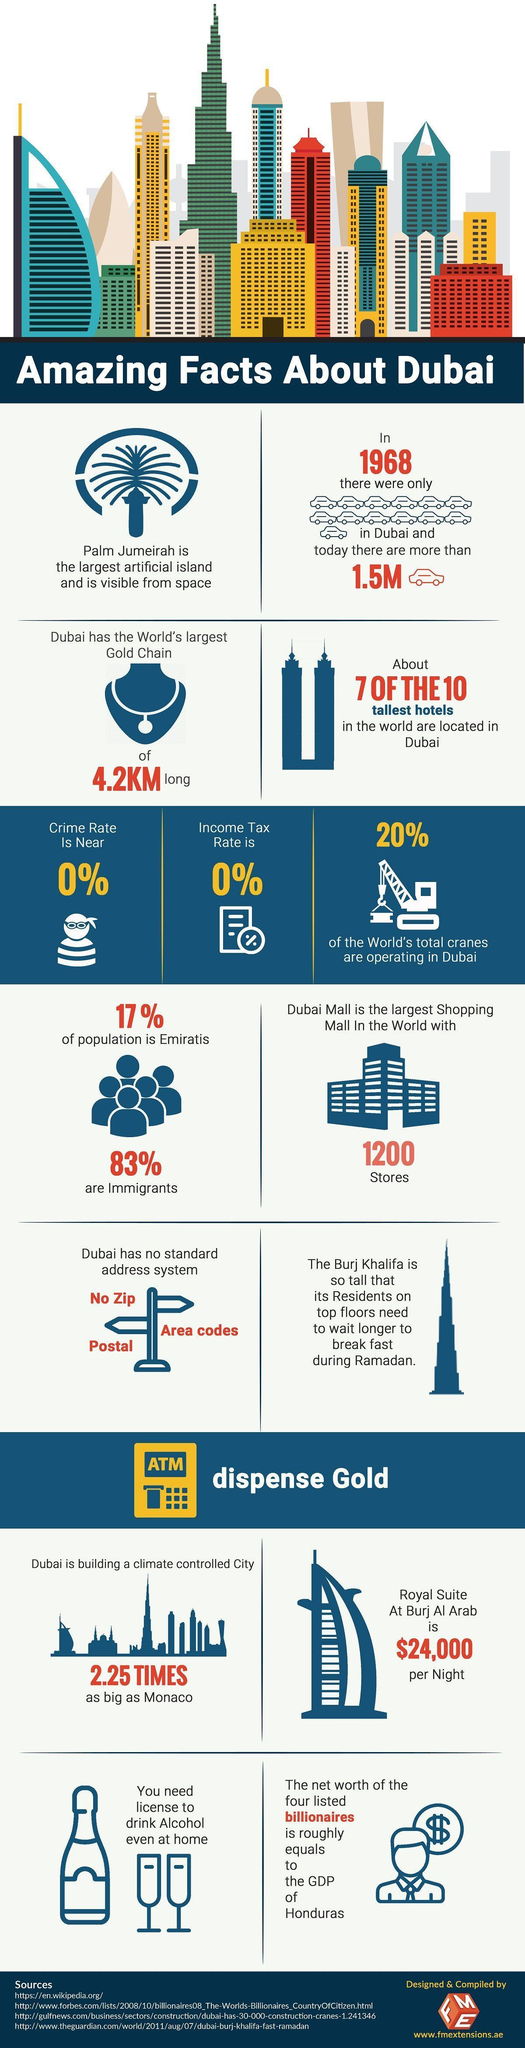How many cars are there in Dubai now?
Answer the question with a short phrase. more than 1.5M What is the length of the gold chain? 4.2KM 